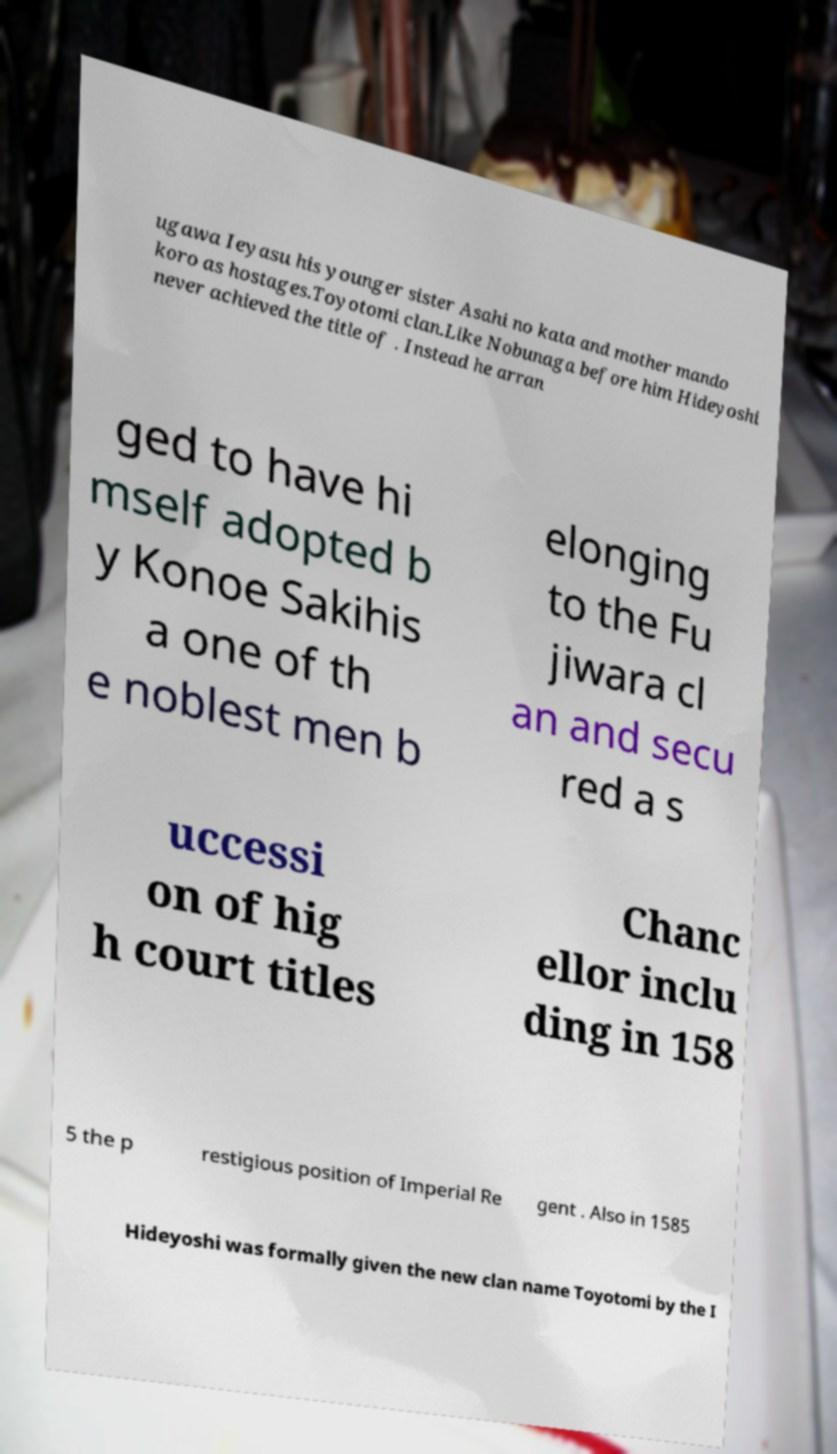Can you read and provide the text displayed in the image?This photo seems to have some interesting text. Can you extract and type it out for me? ugawa Ieyasu his younger sister Asahi no kata and mother mando koro as hostages.Toyotomi clan.Like Nobunaga before him Hideyoshi never achieved the title of . Instead he arran ged to have hi mself adopted b y Konoe Sakihis a one of th e noblest men b elonging to the Fu jiwara cl an and secu red a s uccessi on of hig h court titles Chanc ellor inclu ding in 158 5 the p restigious position of Imperial Re gent . Also in 1585 Hideyoshi was formally given the new clan name Toyotomi by the I 